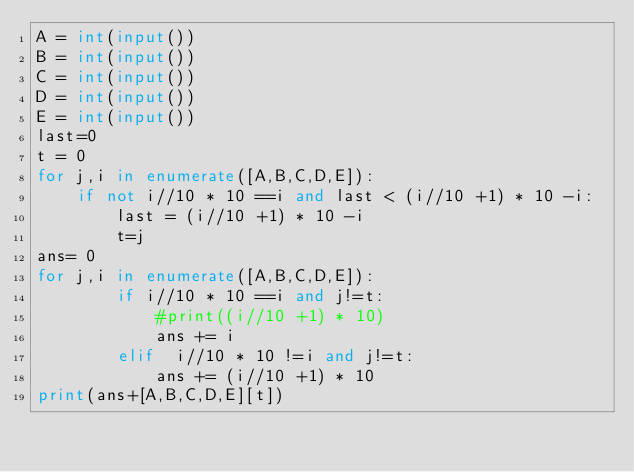<code> <loc_0><loc_0><loc_500><loc_500><_Python_>A = int(input())
B = int(input())
C = int(input())
D = int(input())
E = int(input())
last=0
t = 0
for j,i in enumerate([A,B,C,D,E]):
    if not i//10 * 10 ==i and last < (i//10 +1) * 10 -i:
        last = (i//10 +1) * 10 -i
        t=j
ans= 0
for j,i in enumerate([A,B,C,D,E]):
        if i//10 * 10 ==i and j!=t:
            #print((i//10 +1) * 10)
            ans += i
        elif  i//10 * 10 !=i and j!=t:
            ans += (i//10 +1) * 10
print(ans+[A,B,C,D,E][t])</code> 